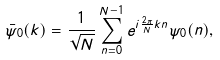Convert formula to latex. <formula><loc_0><loc_0><loc_500><loc_500>\bar { \psi } _ { 0 } ( k ) = \frac { 1 } { \sqrt { N } } \sum _ { n = 0 } ^ { N - 1 } e ^ { i \frac { 2 \pi } { N } k n } { \psi } _ { 0 } ( n ) ,</formula> 